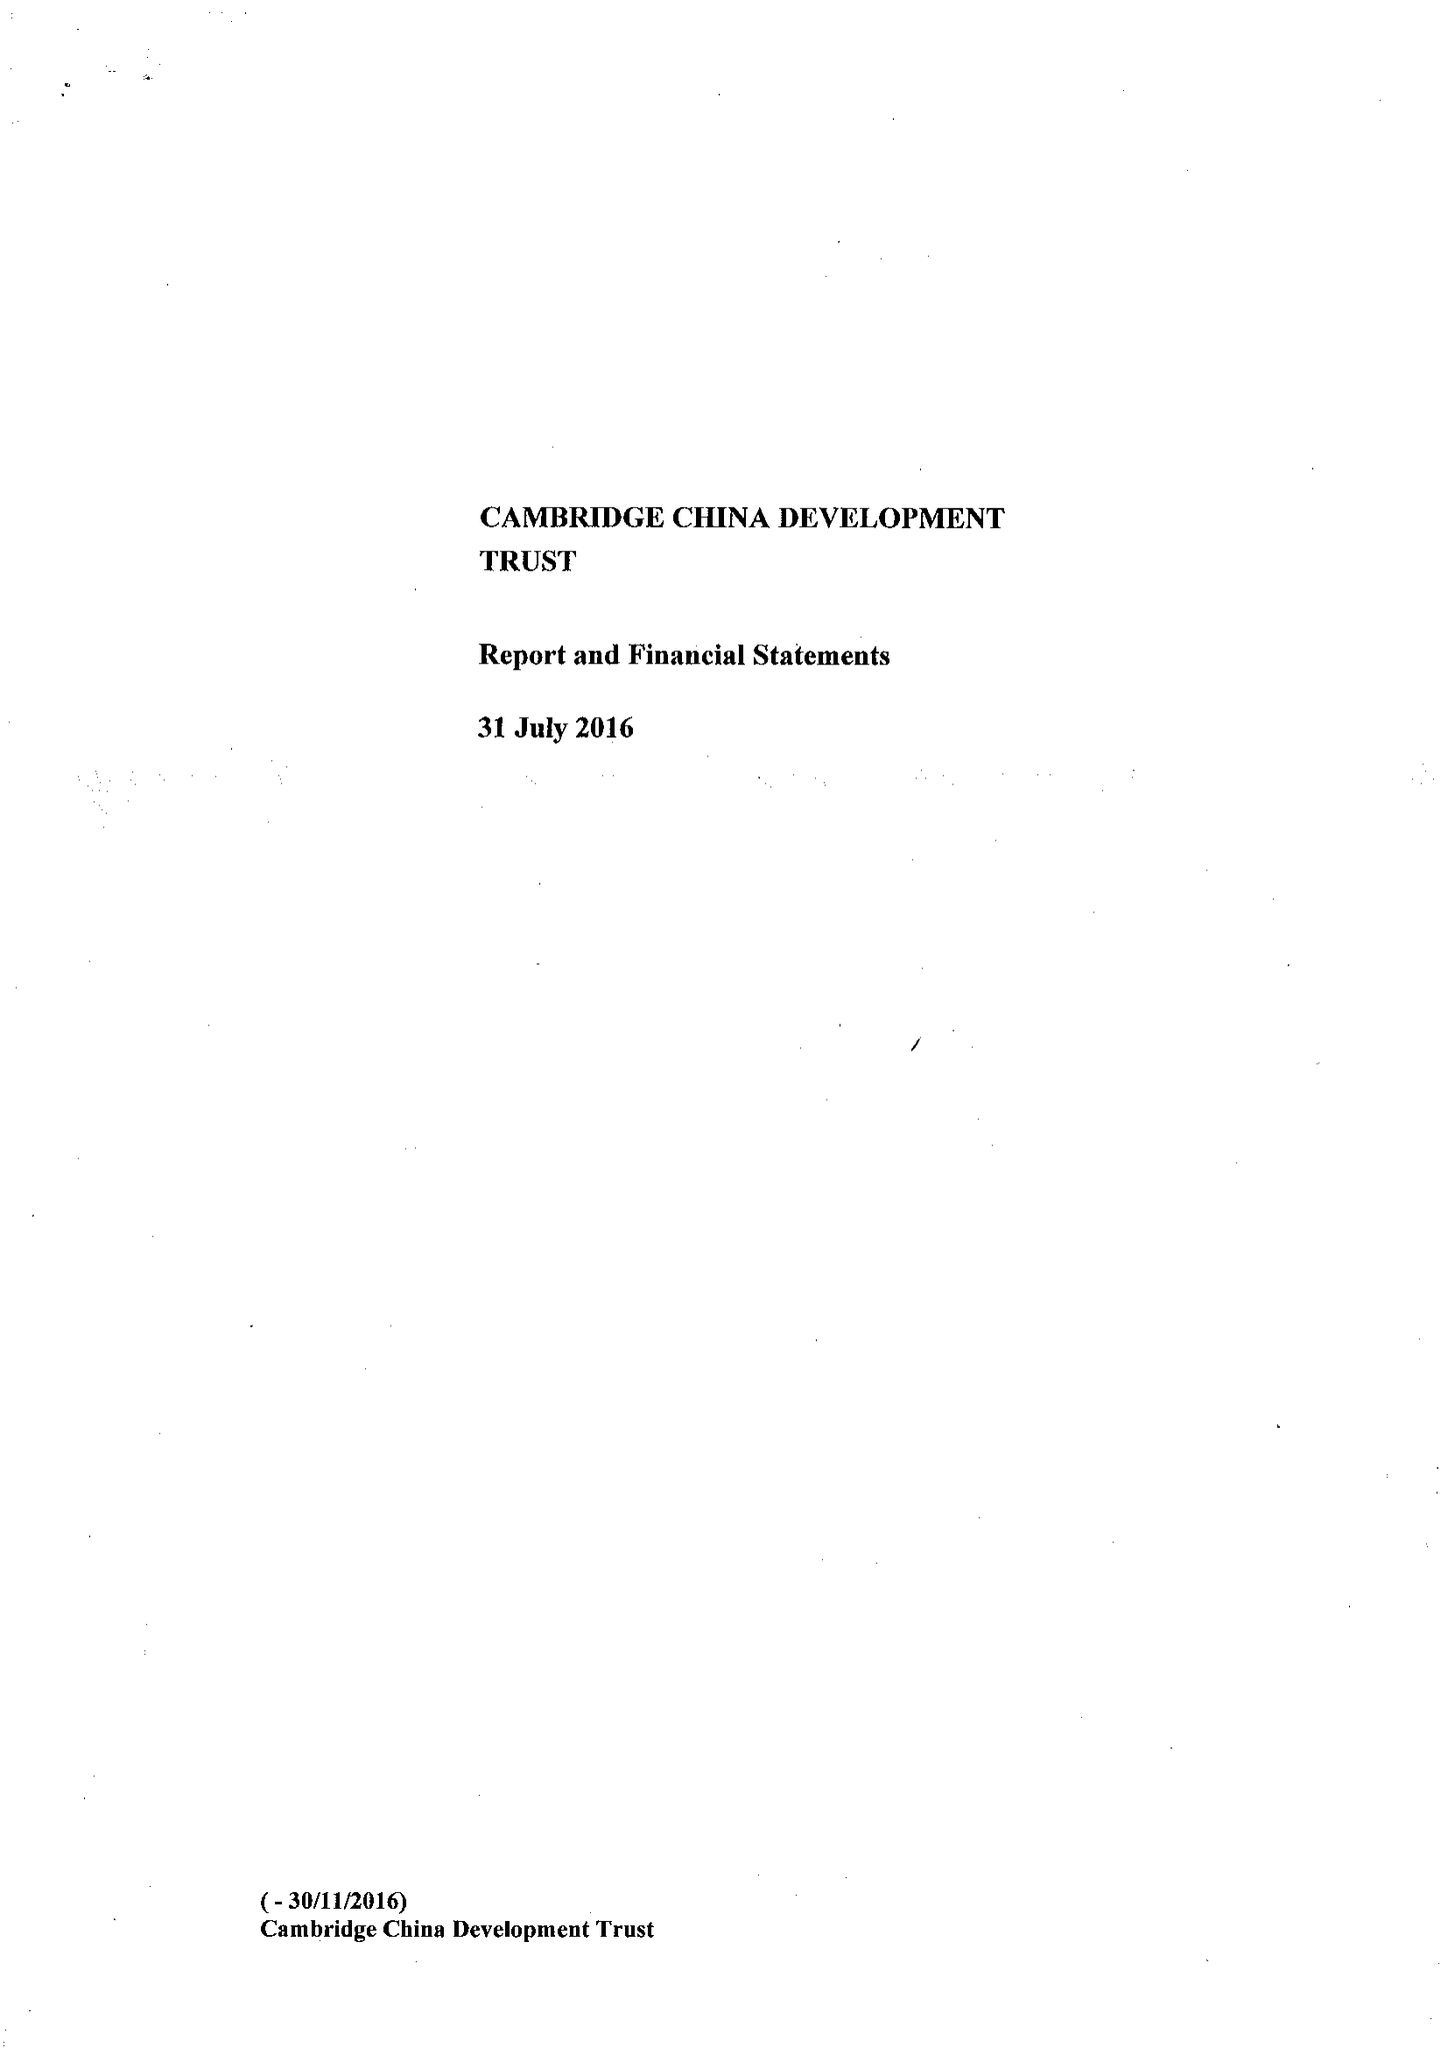What is the value for the charity_name?
Answer the question using a single word or phrase. The Cambridge China Development Trust 